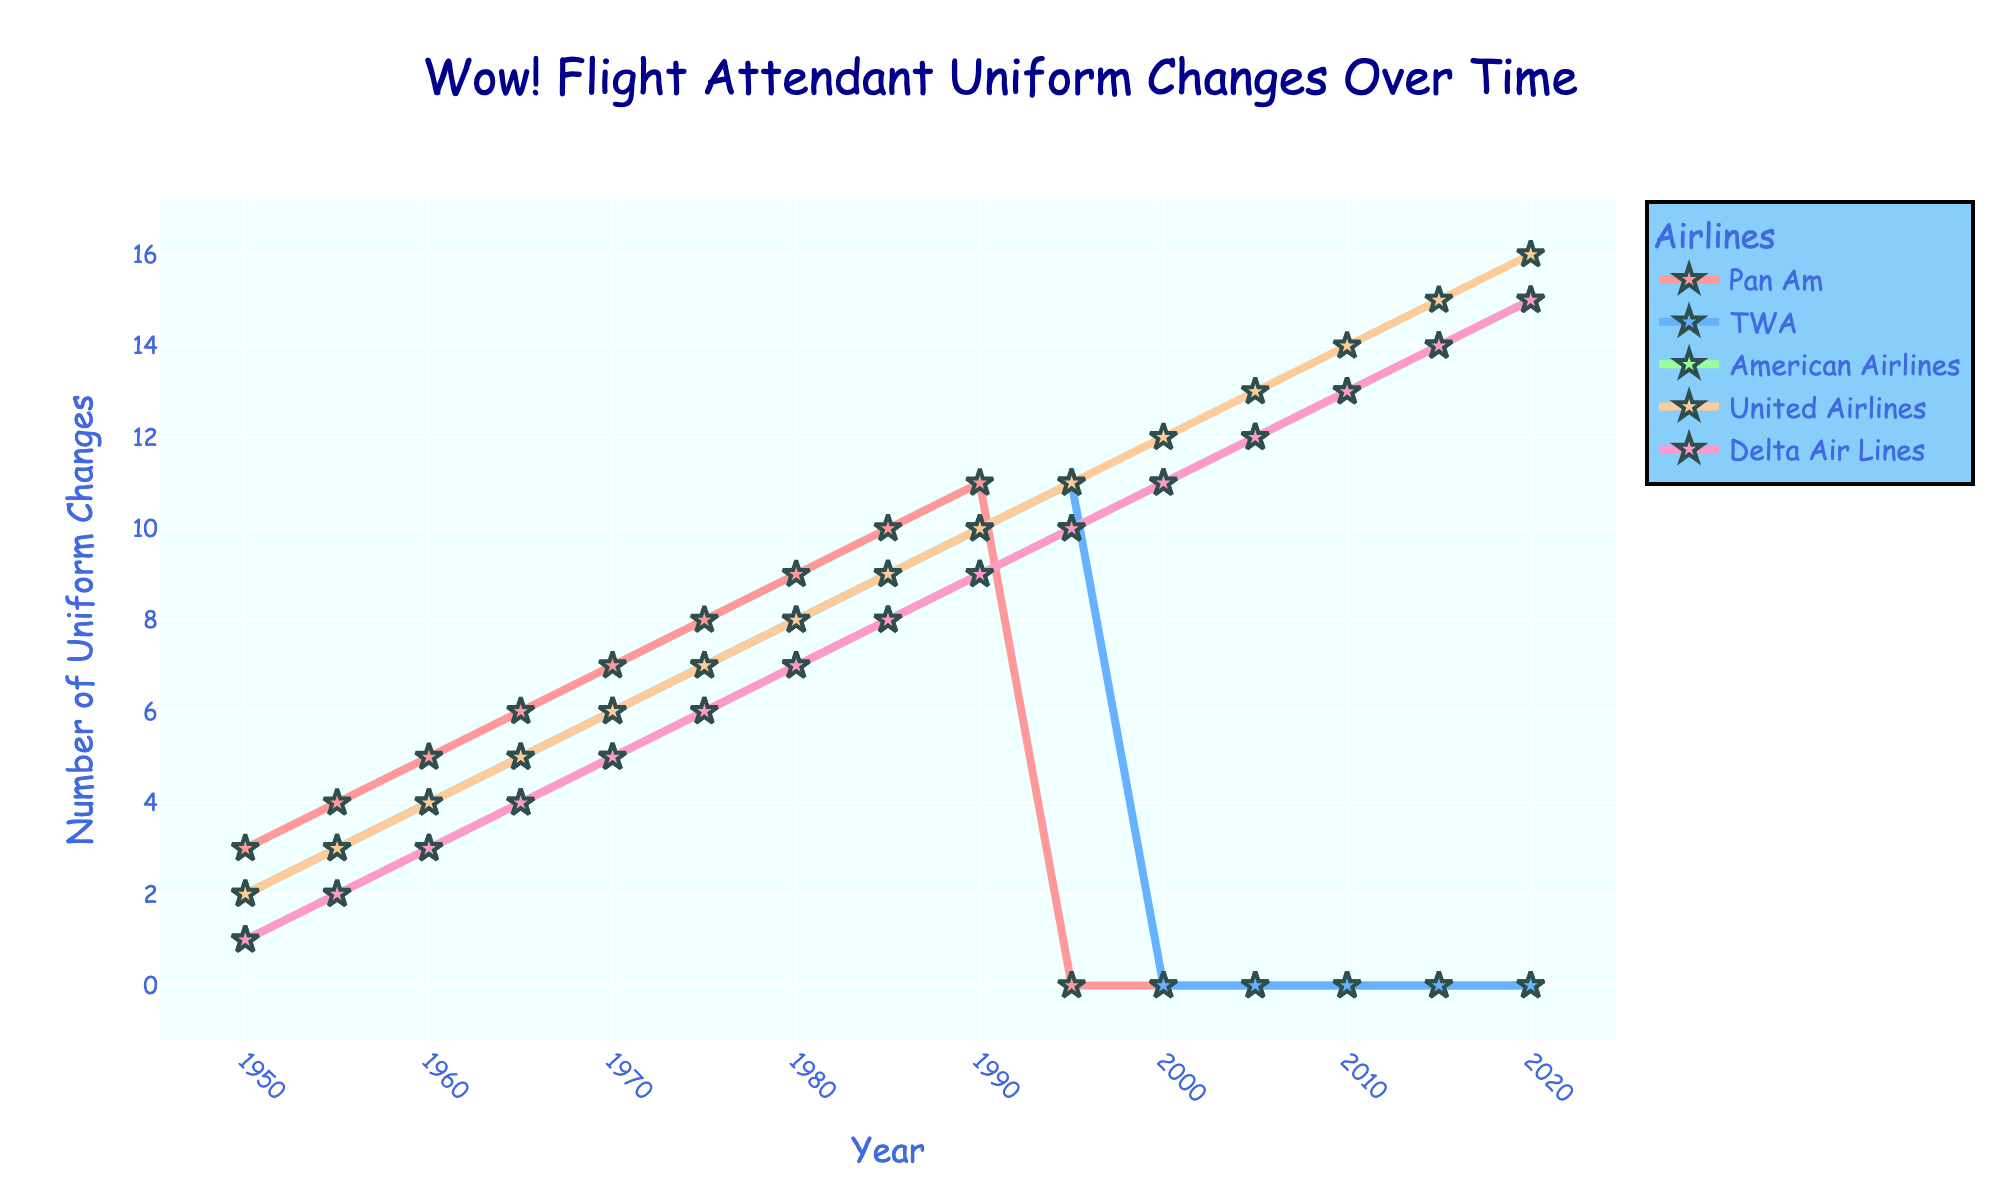What year did Pan Am's uniform changes disappear from the chart? Look for the year when the line representing Pan Am stops appearing. The line for Pan Am stops after 1990.
Answer: 1995 Which airline had the most uniform changes in 2020? Find the line that reaches the highest value in the year 2020. The United Airlines line is at 16 in 2020.
Answer: United Airlines Between 1950 and 2020, which airline showed the most continuous increase in uniform changes? Compare the slope of the lines for all airlines over the years. United Airlines shows a continuous increase without any drop.
Answer: United Airlines How many uniform changes did Delta Air Lines have in 1980? Locate Delta Air Lines' line and check its value at the year 1980. The value is 7.
Answer: 7 Compare the number of uniform changes for TWA and Delta Air Lines in 1960. Which had more and by how much? Look at the values for TWA and Delta Air Lines in 1960. TWA is at 4 and Delta Air Lines is at 3. The difference is 1.
Answer: TWA, by 1 What is the average number of uniform changes for American Airlines from 1950 to 1970? Sum the values for American Airlines from 1950 to 1970 and divide by the number of data points (5). (1+2+3+4+5) / 5 = 3
Answer: 3 What's the total number of uniform changes for TWA from 1950 to 1990? Sum the values for TWA from 1950 to 1990. (2+3+4+5+6+7+8+9+10) = 54
Answer: 54 Which airline(s) have zero uniform changes in multiple years? Check for airlines that have a line touching zero multiple times. Pan Am and TWA have zero uniform changes in multiple years.
Answer: Pan Am, TWA Did any airline have the same number of uniform changes in two consecutive years? If yes, which airline and years? Look for flat segments in any line representing no change between consecutive years. American Airlines had the same number (10) in 1990 and 1995.
Answer: American Airlines, 1990 and 1995 How does the trend for Delta Air Lines compare to TWA from 1950 to 1985? Observe the slopes of the lines for both airlines from 1950 to 1985 to determine if one increases faster or if they are similar. TWA consistently increases while Delta has a similar increasing trend but with slightly lower values.
Answer: Similar, with slight differences 